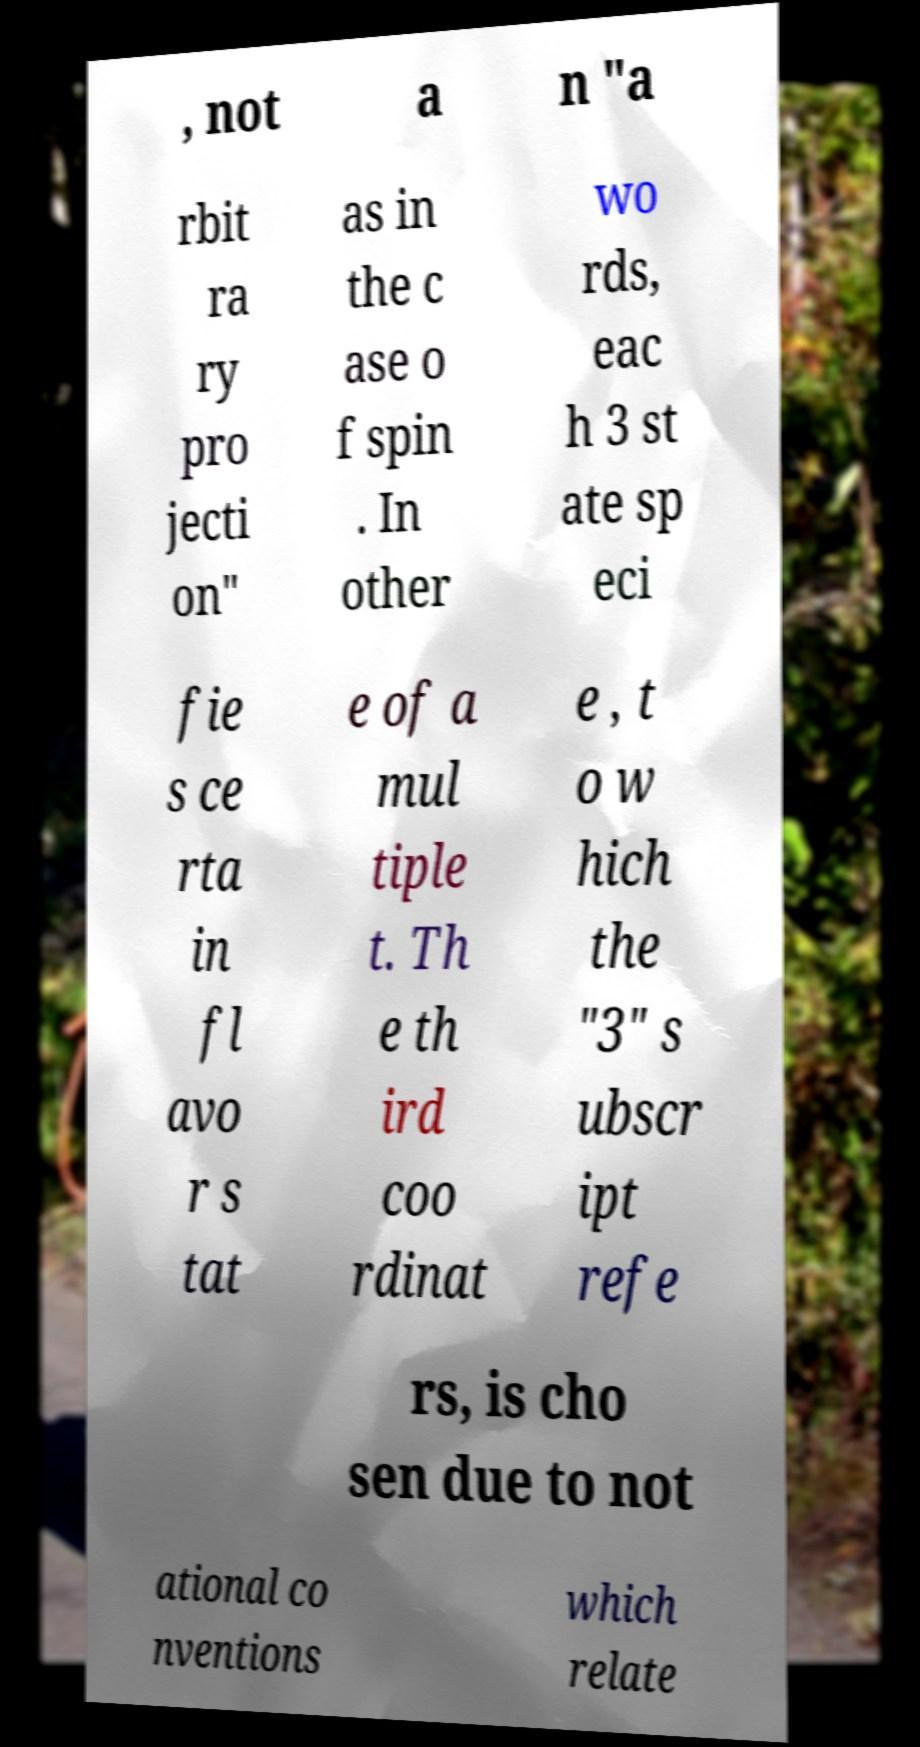There's text embedded in this image that I need extracted. Can you transcribe it verbatim? , not a n "a rbit ra ry pro jecti on" as in the c ase o f spin . In other wo rds, eac h 3 st ate sp eci fie s ce rta in fl avo r s tat e of a mul tiple t. Th e th ird coo rdinat e , t o w hich the "3" s ubscr ipt refe rs, is cho sen due to not ational co nventions which relate 